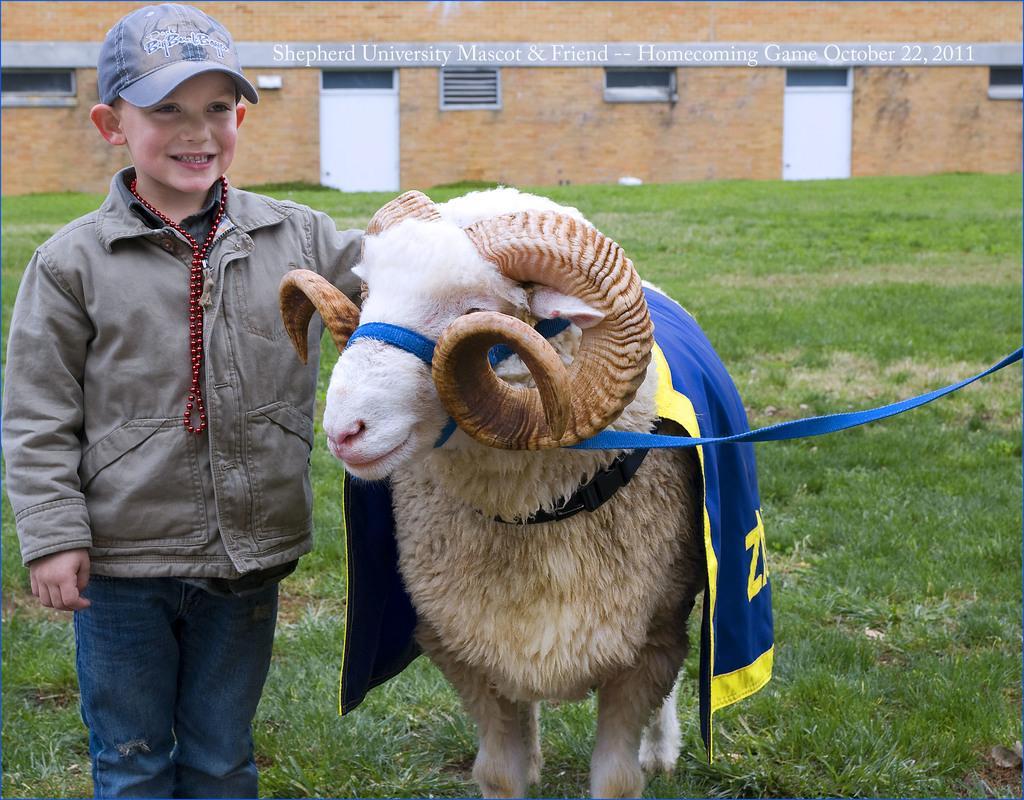Please provide a concise description of this image. This image consists of a sheep on which there is a blue color cloth. Beside that there is a boy standing. At the bottom, there is green grass on the ground. In the background, there is a building along with windows and doors. 